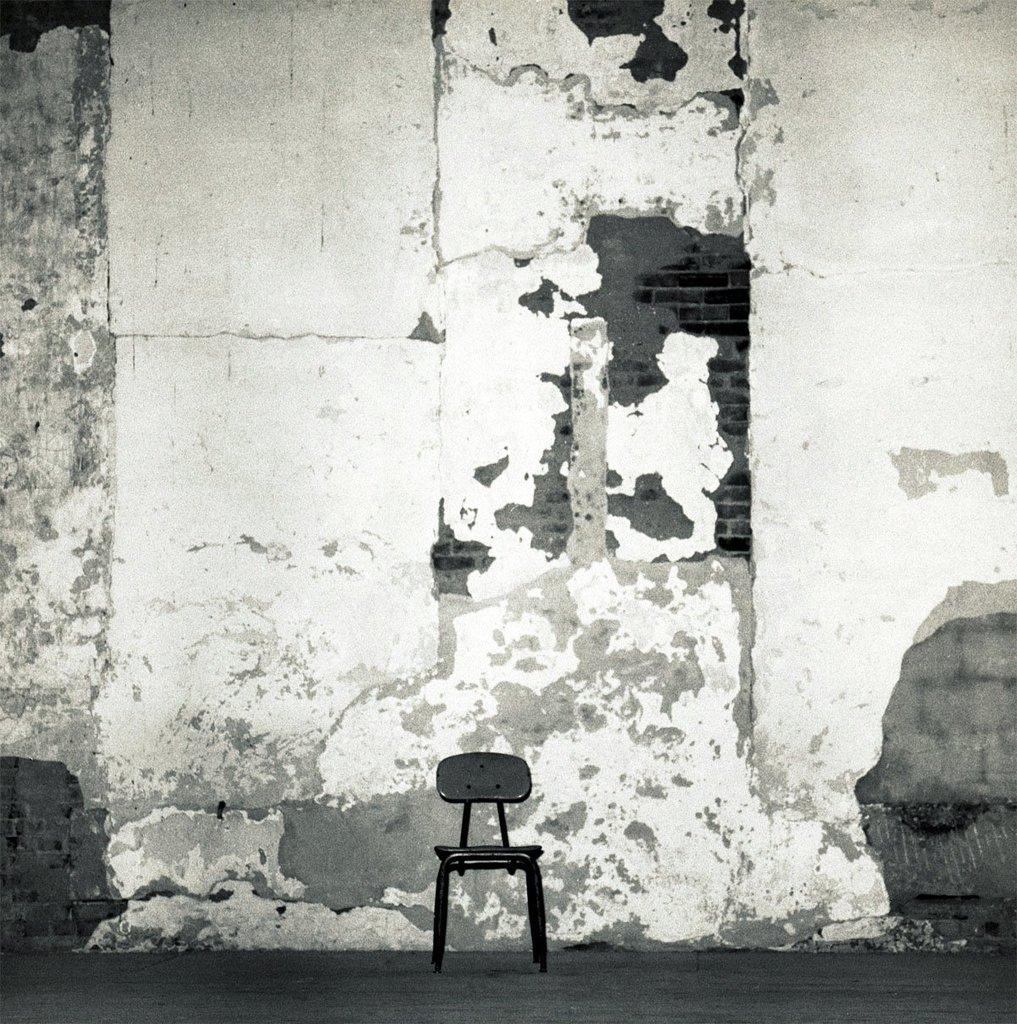What is the color scheme of the image? The image is black and white. What object is located in the middle of the image? There is a chair in the middle of the image. What color is the chair? The chair is black in color. What can be seen behind the chair in the image? There is a wall visible in the image. What color is the wall? The wall is white in color. Can you tell me how many bricks are visible in the image? There are no bricks visible in the image; it features a black and white chair and a white wall. What type of base is supporting the chair in the image? The image does not provide information about the base supporting the chair. 